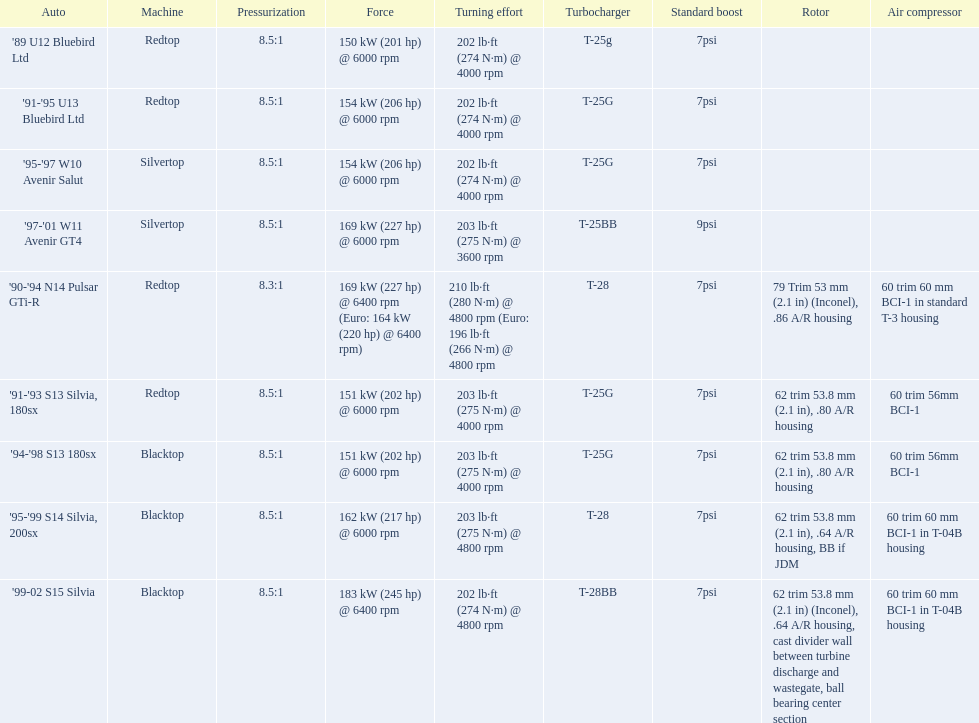Which of the cars uses the redtop engine? '89 U12 Bluebird Ltd, '91-'95 U13 Bluebird Ltd, '90-'94 N14 Pulsar GTi-R, '91-'93 S13 Silvia, 180sx. Of these, has more than 220 horsepower? '90-'94 N14 Pulsar GTi-R. What is the compression ratio of this car? 8.3:1. 